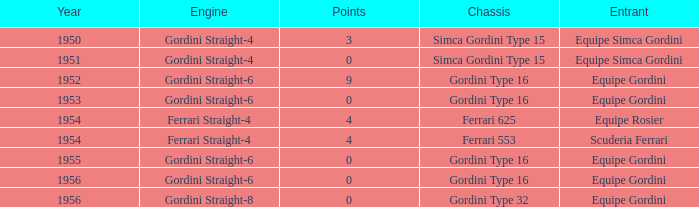Before 1956, what Chassis has Gordini Straight-4 engine with 3 points? Simca Gordini Type 15. 